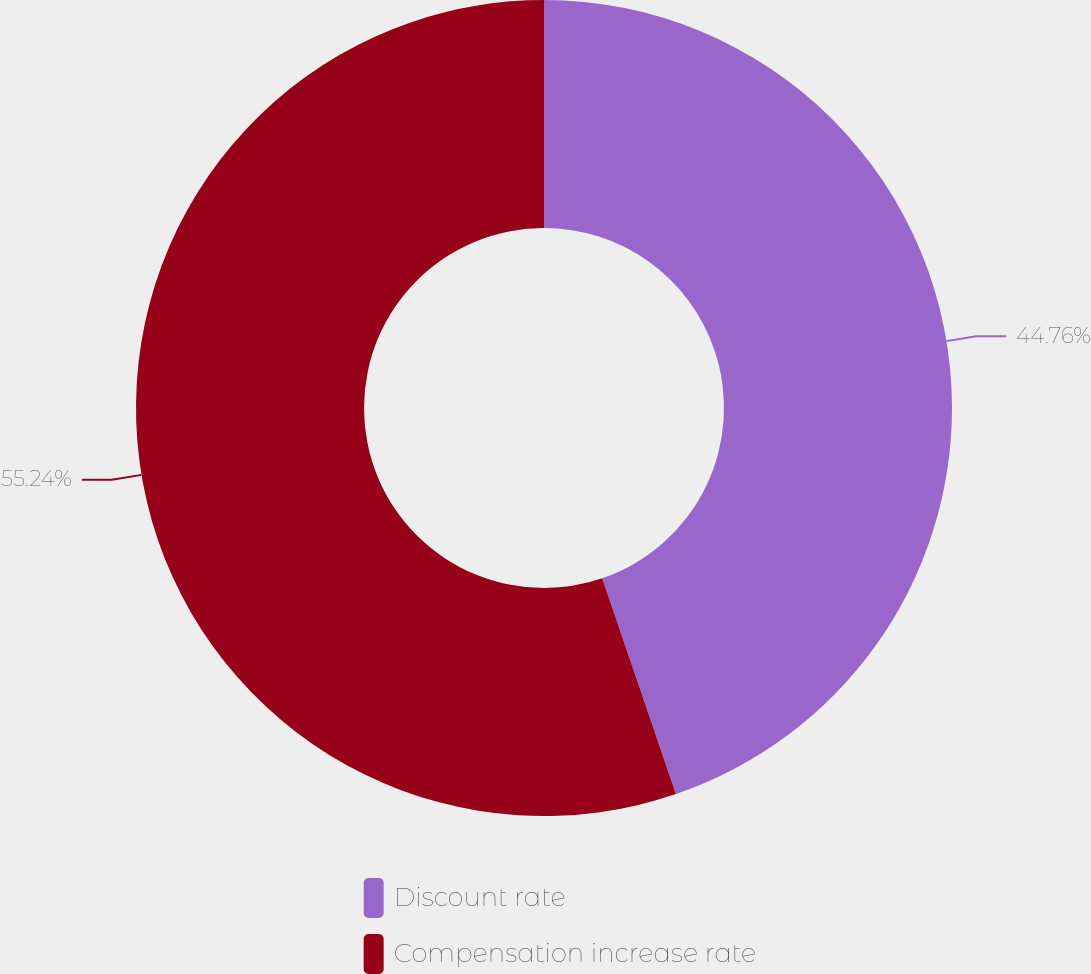Convert chart to OTSL. <chart><loc_0><loc_0><loc_500><loc_500><pie_chart><fcel>Discount rate<fcel>Compensation increase rate<nl><fcel>44.76%<fcel>55.24%<nl></chart> 